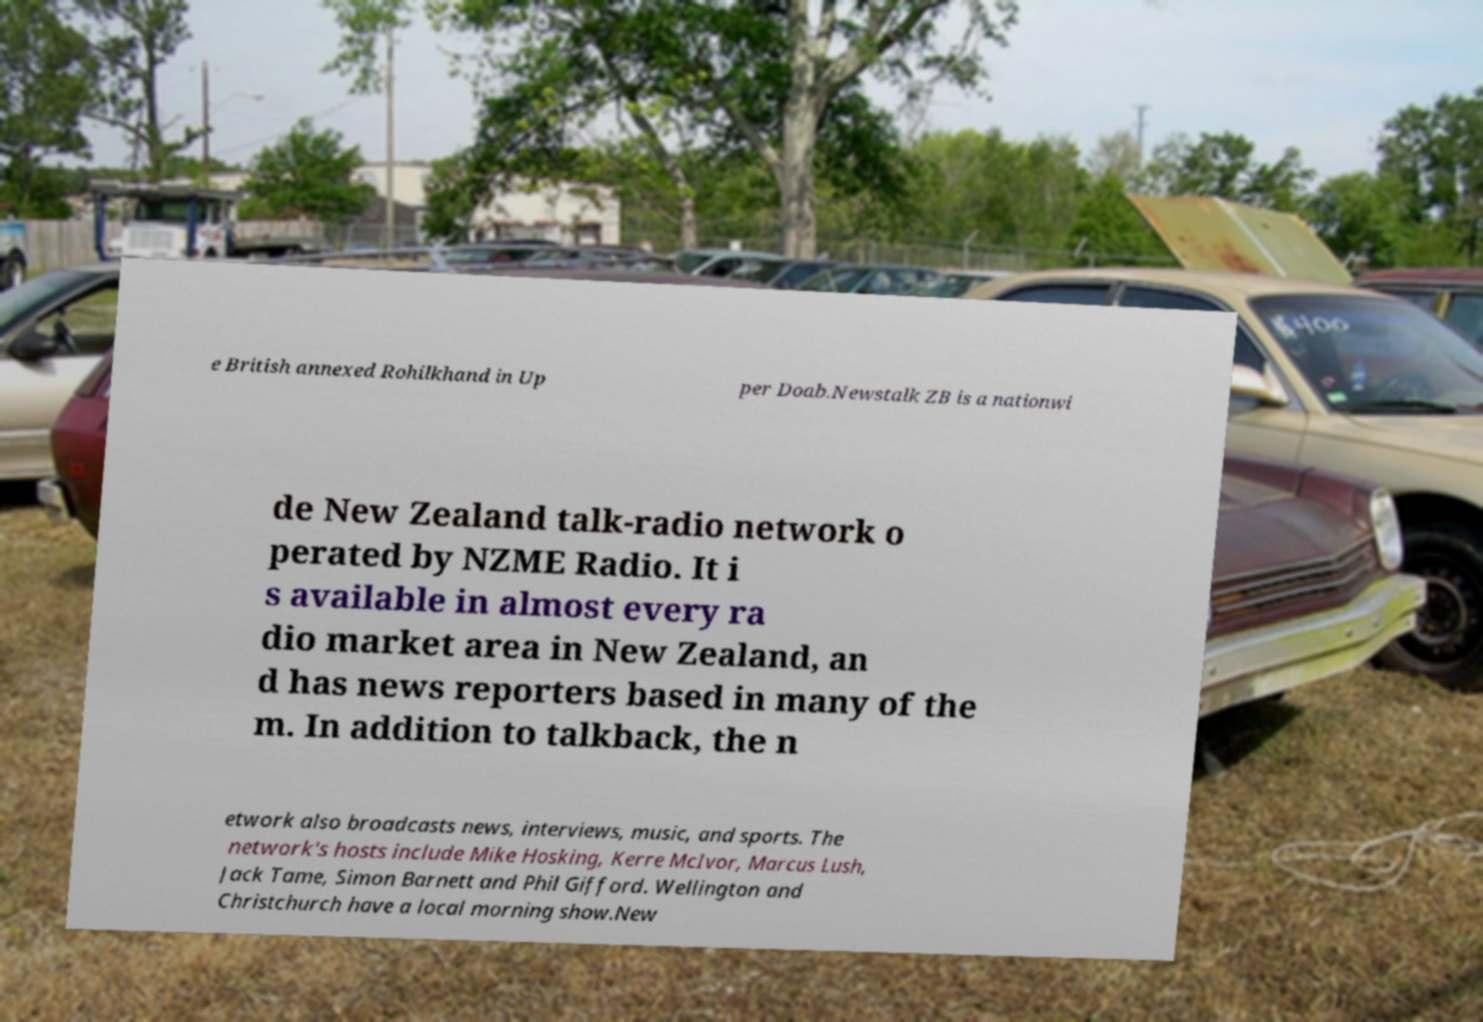Could you extract and type out the text from this image? e British annexed Rohilkhand in Up per Doab.Newstalk ZB is a nationwi de New Zealand talk-radio network o perated by NZME Radio. It i s available in almost every ra dio market area in New Zealand, an d has news reporters based in many of the m. In addition to talkback, the n etwork also broadcasts news, interviews, music, and sports. The network's hosts include Mike Hosking, Kerre McIvor, Marcus Lush, Jack Tame, Simon Barnett and Phil Gifford. Wellington and Christchurch have a local morning show.New 